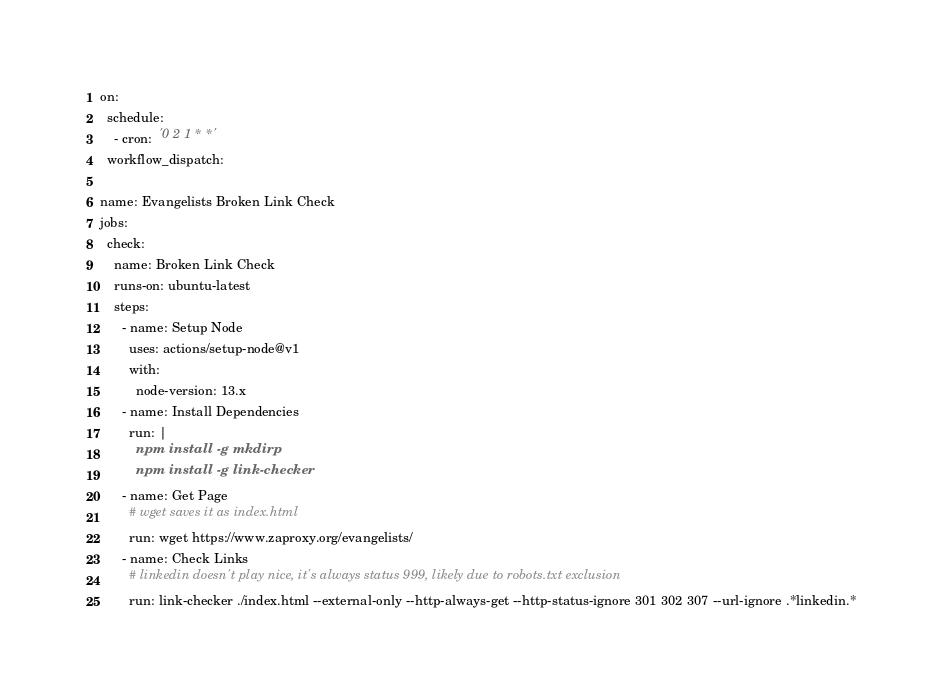Convert code to text. <code><loc_0><loc_0><loc_500><loc_500><_YAML_>on:
  schedule:
    - cron:  '0 2 1 * *'
  workflow_dispatch:

name: Evangelists Broken Link Check
jobs:
  check:
    name: Broken Link Check
    runs-on: ubuntu-latest
    steps:
      - name: Setup Node
        uses: actions/setup-node@v1
        with:
          node-version: 13.x
      - name: Install Dependencies
        run: |
          npm install -g mkdirp
          npm install -g link-checker
      - name: Get Page
        # wget saves it as index.html
        run: wget https://www.zaproxy.org/evangelists/
      - name: Check Links
        # linkedin doesn't play nice, it's always status 999, likely due to robots.txt exclusion
        run: link-checker ./index.html --external-only --http-always-get --http-status-ignore 301 302 307 --url-ignore .*linkedin.*
</code> 